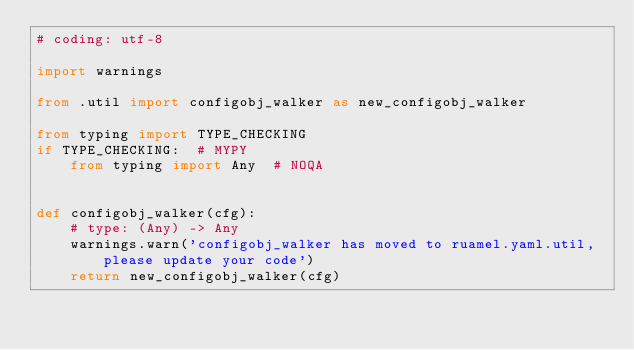<code> <loc_0><loc_0><loc_500><loc_500><_Python_># coding: utf-8

import warnings

from .util import configobj_walker as new_configobj_walker

from typing import TYPE_CHECKING
if TYPE_CHECKING:  # MYPY
    from typing import Any  # NOQA


def configobj_walker(cfg):
    # type: (Any) -> Any
    warnings.warn('configobj_walker has moved to ruamel.yaml.util, please update your code')
    return new_configobj_walker(cfg)
</code> 